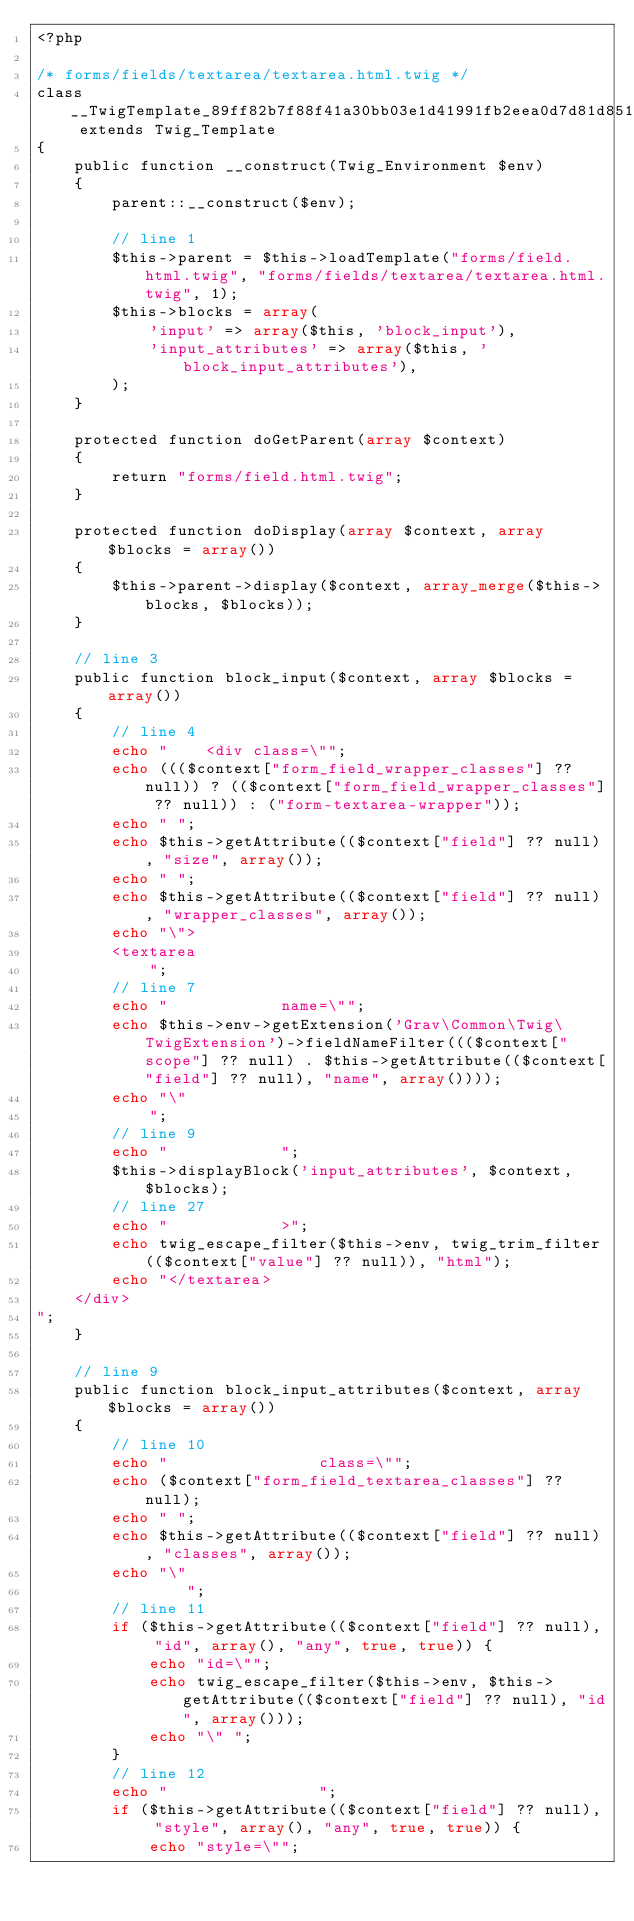Convert code to text. <code><loc_0><loc_0><loc_500><loc_500><_PHP_><?php

/* forms/fields/textarea/textarea.html.twig */
class __TwigTemplate_89ff82b7f88f41a30bb03e1d41991fb2eea0d7d81d8512c643b209e479d2e04e extends Twig_Template
{
    public function __construct(Twig_Environment $env)
    {
        parent::__construct($env);

        // line 1
        $this->parent = $this->loadTemplate("forms/field.html.twig", "forms/fields/textarea/textarea.html.twig", 1);
        $this->blocks = array(
            'input' => array($this, 'block_input'),
            'input_attributes' => array($this, 'block_input_attributes'),
        );
    }

    protected function doGetParent(array $context)
    {
        return "forms/field.html.twig";
    }

    protected function doDisplay(array $context, array $blocks = array())
    {
        $this->parent->display($context, array_merge($this->blocks, $blocks));
    }

    // line 3
    public function block_input($context, array $blocks = array())
    {
        // line 4
        echo "    <div class=\"";
        echo ((($context["form_field_wrapper_classes"] ?? null)) ? (($context["form_field_wrapper_classes"] ?? null)) : ("form-textarea-wrapper"));
        echo " ";
        echo $this->getAttribute(($context["field"] ?? null), "size", array());
        echo " ";
        echo $this->getAttribute(($context["field"] ?? null), "wrapper_classes", array());
        echo "\">
        <textarea
            ";
        // line 7
        echo "            name=\"";
        echo $this->env->getExtension('Grav\Common\Twig\TwigExtension')->fieldNameFilter((($context["scope"] ?? null) . $this->getAttribute(($context["field"] ?? null), "name", array())));
        echo "\"
            ";
        // line 9
        echo "            ";
        $this->displayBlock('input_attributes', $context, $blocks);
        // line 27
        echo "            >";
        echo twig_escape_filter($this->env, twig_trim_filter(($context["value"] ?? null)), "html");
        echo "</textarea>
    </div>
";
    }

    // line 9
    public function block_input_attributes($context, array $blocks = array())
    {
        // line 10
        echo "                class=\"";
        echo ($context["form_field_textarea_classes"] ?? null);
        echo " ";
        echo $this->getAttribute(($context["field"] ?? null), "classes", array());
        echo "\"
                ";
        // line 11
        if ($this->getAttribute(($context["field"] ?? null), "id", array(), "any", true, true)) {
            echo "id=\"";
            echo twig_escape_filter($this->env, $this->getAttribute(($context["field"] ?? null), "id", array()));
            echo "\" ";
        }
        // line 12
        echo "                ";
        if ($this->getAttribute(($context["field"] ?? null), "style", array(), "any", true, true)) {
            echo "style=\"";</code> 